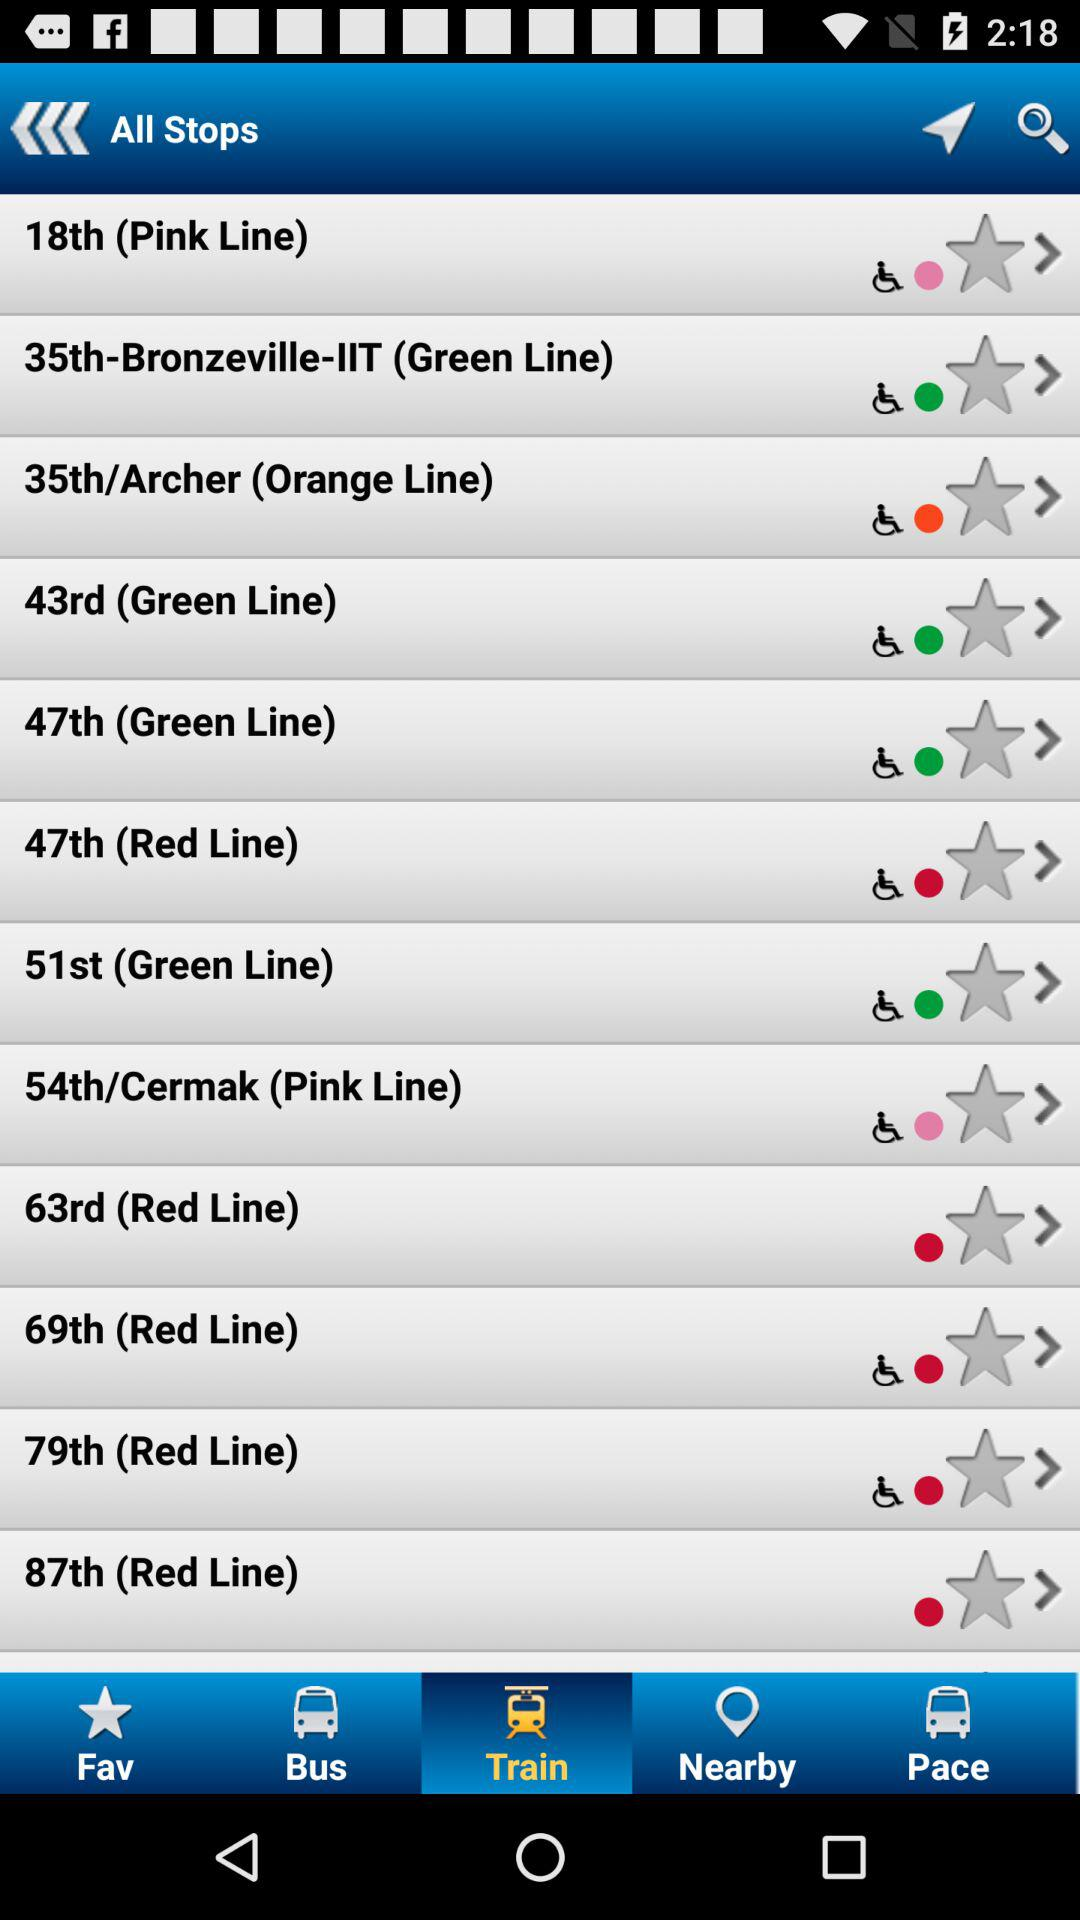Which stop is on the Orange Line? The stop on the Orange Line is "35th/Archer". 